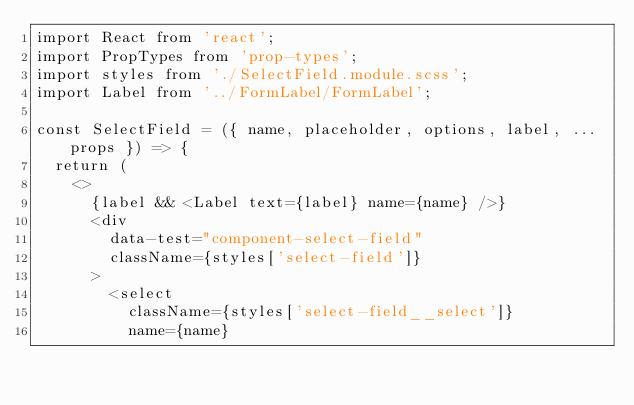Convert code to text. <code><loc_0><loc_0><loc_500><loc_500><_JavaScript_>import React from 'react';
import PropTypes from 'prop-types';
import styles from './SelectField.module.scss';
import Label from '../FormLabel/FormLabel';

const SelectField = ({ name, placeholder, options, label, ...props }) => {
  return (
    <>
      {label && <Label text={label} name={name} />}
      <div
        data-test="component-select-field"
        className={styles['select-field']}
      >
        <select
          className={styles['select-field__select']}
          name={name}</code> 